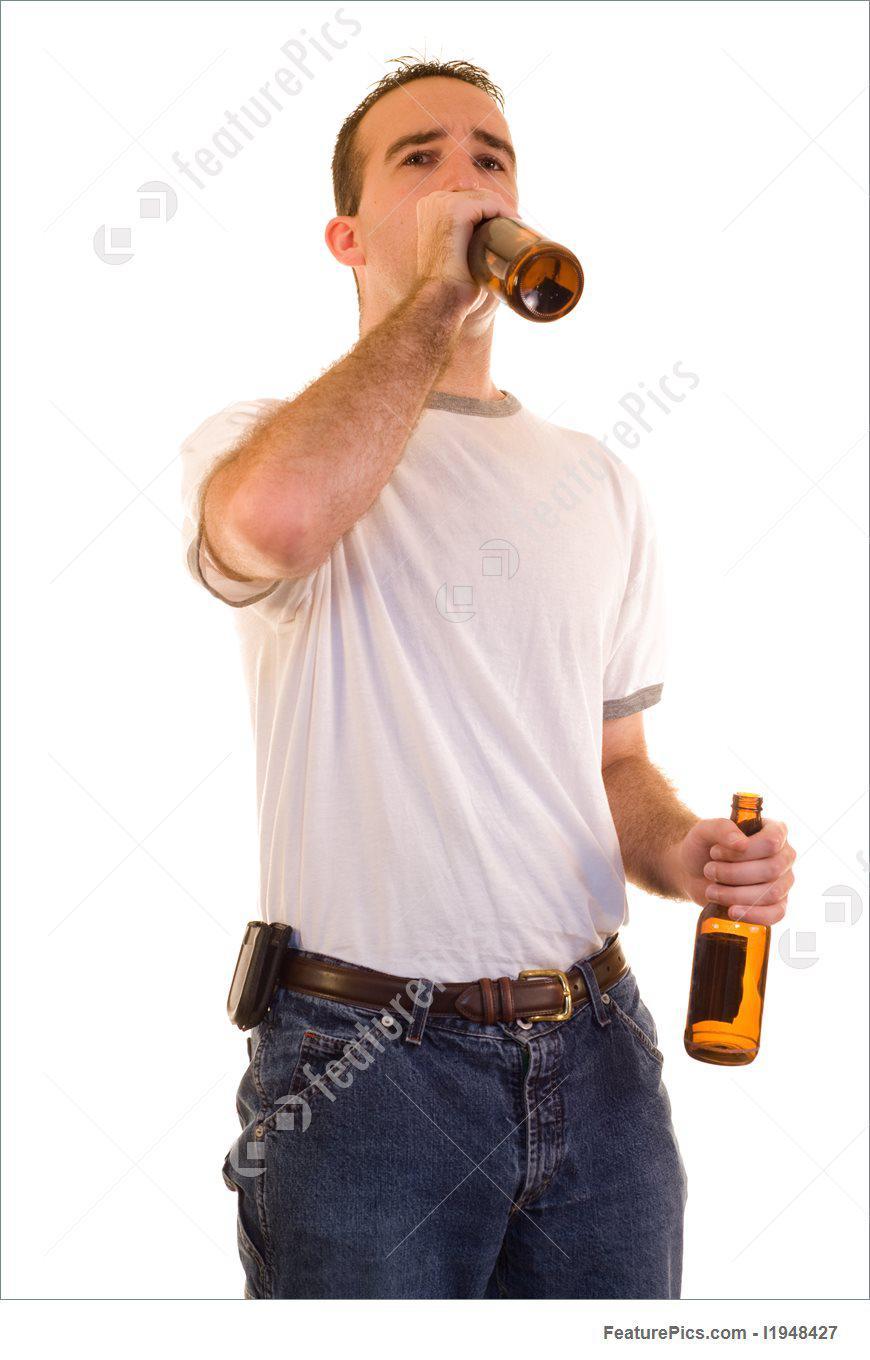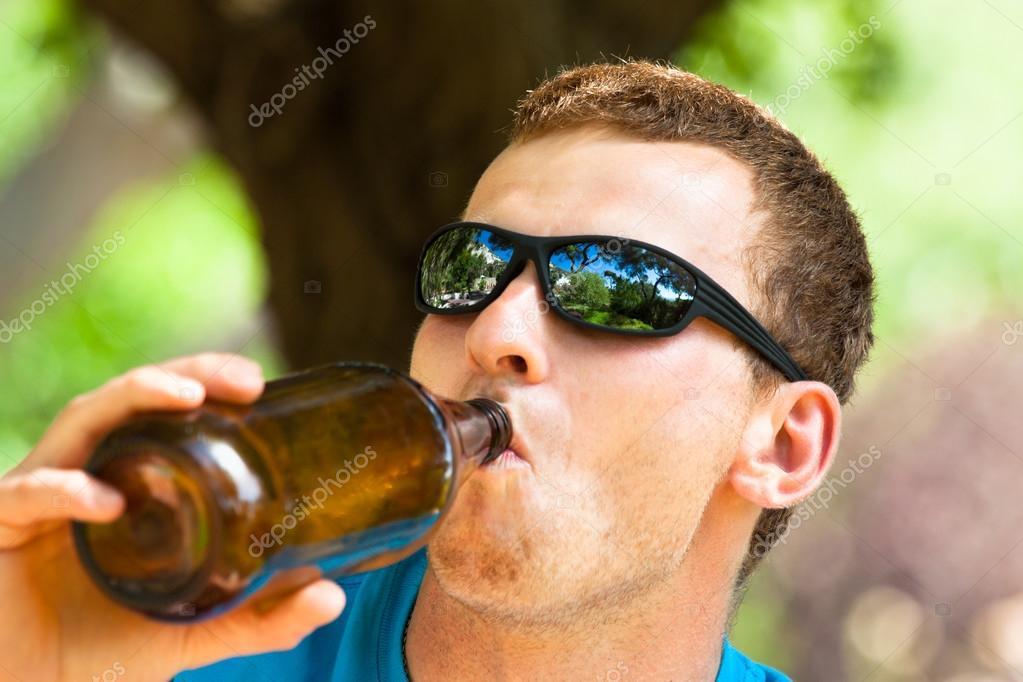The first image is the image on the left, the second image is the image on the right. For the images shown, is this caption "The men in both images are drinking beer, touching the bottle to their lips." true? Answer yes or no. Yes. 